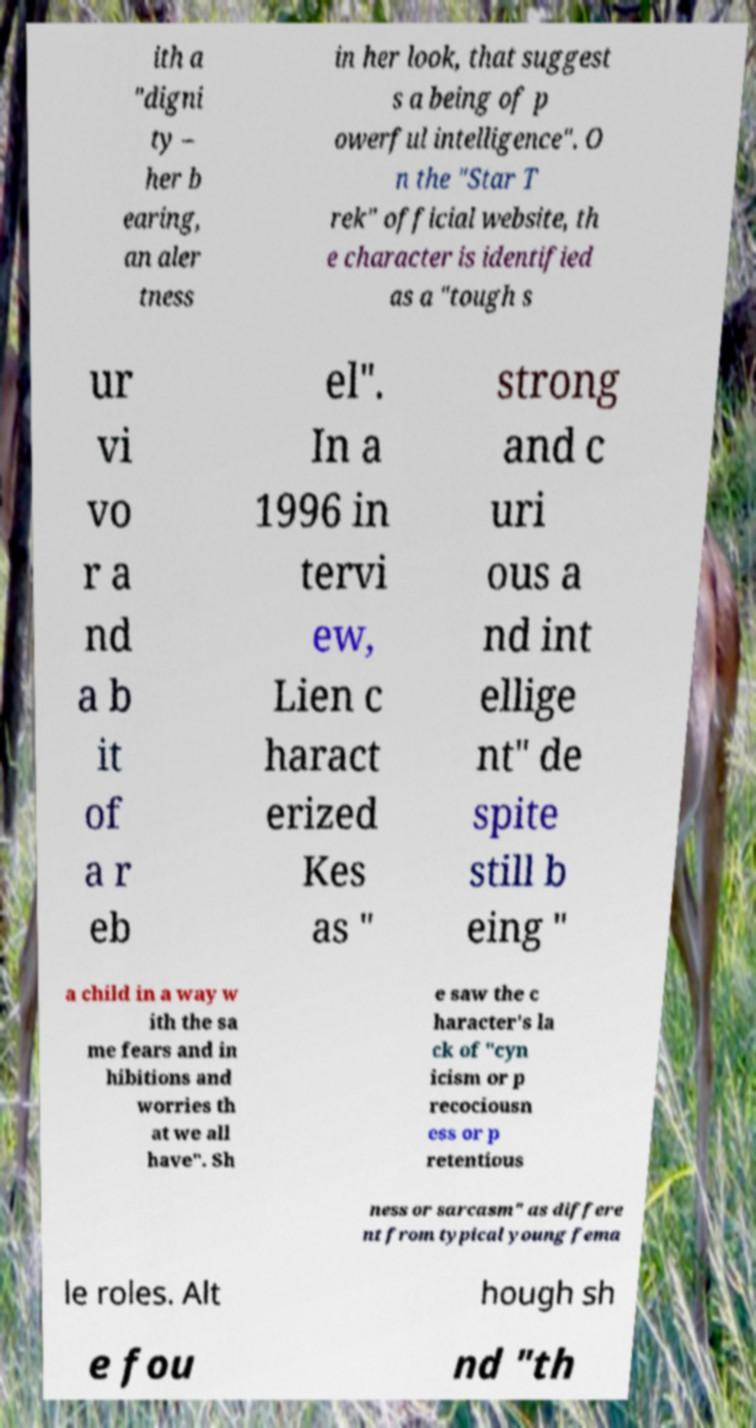Could you assist in decoding the text presented in this image and type it out clearly? ith a "digni ty – her b earing, an aler tness in her look, that suggest s a being of p owerful intelligence". O n the "Star T rek" official website, th e character is identified as a "tough s ur vi vo r a nd a b it of a r eb el". In a 1996 in tervi ew, Lien c haract erized Kes as " strong and c uri ous a nd int ellige nt" de spite still b eing " a child in a way w ith the sa me fears and in hibitions and worries th at we all have". Sh e saw the c haracter's la ck of "cyn icism or p recociousn ess or p retentious ness or sarcasm" as differe nt from typical young fema le roles. Alt hough sh e fou nd "th 